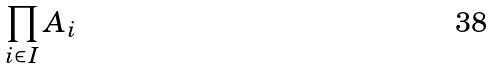<formula> <loc_0><loc_0><loc_500><loc_500>\prod _ { i \in I } A _ { i }</formula> 